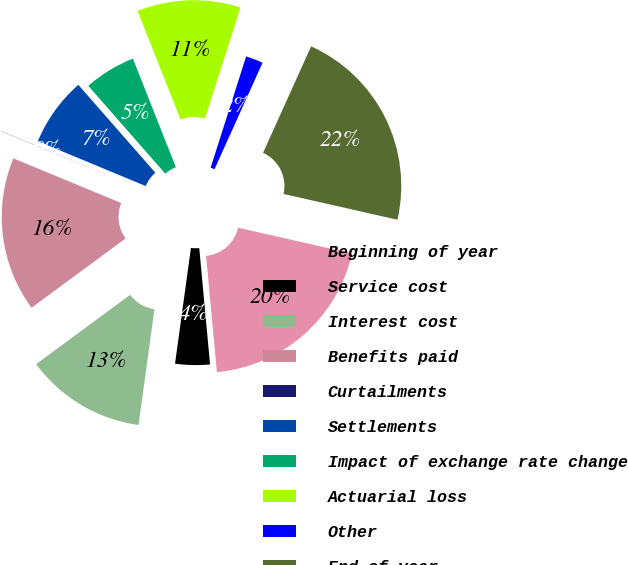Convert chart. <chart><loc_0><loc_0><loc_500><loc_500><pie_chart><fcel>Beginning of year<fcel>Service cost<fcel>Interest cost<fcel>Benefits paid<fcel>Curtailments<fcel>Settlements<fcel>Impact of exchange rate change<fcel>Actuarial loss<fcel>Other<fcel>End of year<nl><fcel>19.98%<fcel>3.65%<fcel>12.72%<fcel>16.35%<fcel>0.02%<fcel>7.28%<fcel>5.46%<fcel>10.91%<fcel>1.83%<fcel>21.8%<nl></chart> 